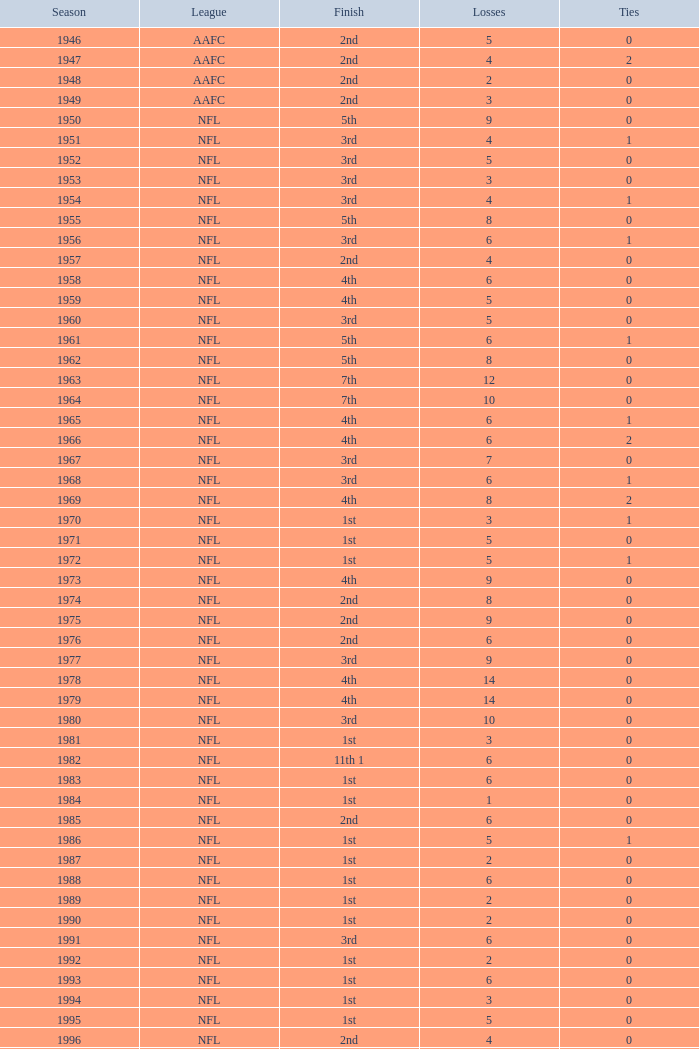What is the highest wins for the NFL with a finish of 1st, and more than 6 losses? None. 